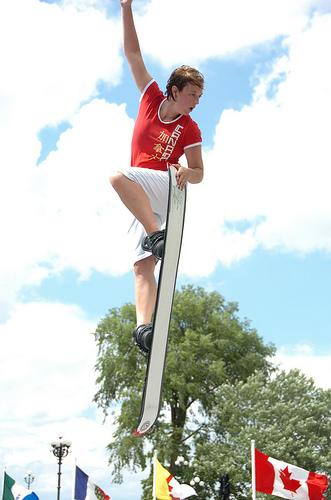Mention the visible parts of a flag pole and provide the dimensions. Part of a white flag pole is visible, with dimensions of width 10 and height 10. In the image, describe the type of shirt worn by the woman performing the snowboarding trick. The woman wears a red and white shirt with short sleeves, with dimensions of width 72 and height 72. Describe the sentiment or overall mood conveyed by the image. The image conveys a lively and energetic mood, with the flags representing different countries in a row and the woman performing an exciting snowboarding trick against a bright blue sky backdrop. What is the backdrop for the scene with the flags and the woman on the snowboard? The backdrop consists of white clouds in a blue sky, green leaves on trees, and a row of flags of different countries. What is the woman with short hair doing in the picture? The woman with short hair is performing a snowboarding trick, jumping in the air while maintaining her balance. Describe the appearance of the street lamp in the image. The street lamp has white globes and old-style design placed on a tall pole with lights on top, all set against a clear blue sky. What kind of shorts does the boy in the image wear, and what are the dimensions of the shorts? The boy wears white shorts with dimensions of width 58 and height 58. Tell me about the flags in this image. There are multiple flags of different countries in a row, including a red and white Canadian flag with a maple leaf, as well as a blue and white flag. How many hands are touching the snowboard and where are they located? There are two hands touching the snowboard - the left hand on the board and another hand on the bottom of the snowboard. Identify the presence of any trees in the image and provide their dimensions. There is a large green tree with width 183 and height 183, partially obscured by flags. What is the content of the writing containing stacked letters? There are no clear words or phrases with stacked letters. Choose the correct answer about the woman's shirt: (a) blue with long sleeves, (b) red with short sleeves, (c) green with no sleeves. (b) red with short sleeves. Identify the two predominate colors on the Canadian flag. The Canadian flag is red and white. What is the predominant color on the flag next to the Canadian flag? The flag's predominant color is blue and white. Write a sentence describing the sky's appearance. The sky is blue with white clouds. Explain the spatial relationship between the flags and the trees. The flags are in the foreground, partially obscuring the trees in the background. Describe the characteristics of the street lamp. The street lamp has white globes and appears to be an older style. Describe the tree seen behind the rows of flags. The tree is large and green, partially obscured by the flags. How many trees can be seen behind the row of flags? There are two trees partially obscured by the flags. Create a short poem inspiring viewers to participate in thrilling snow sports like the female snowboarder in the image. Through wind and snow she flies, What is the content of the writing contained by the white board with black and red trim? There is no clear writing or text on the white board with black and red trim. What is the action being performed by the boy in the image? There isn't enough detail to determine the boy's action in the image. Is there an event happening in the image that involves the woman? Yes, the woman is performing a snowboarding trick or jump. Is there an event happening in the image that involves multiple flags? Yes, there is a row of flags from different countries in the image. What activity is the woman performing on the snowboard? The woman is performing a snowboarding trick or jump. What color are the lights on top of the pole? The lights on top of the pole are white. Describe the woman's outfit while she performs the snowboarding trick. The woman has short brown hair, a red and white shirt, and white shorts. What is the total number of flags shown in the image? There are 13 flags in the image. 